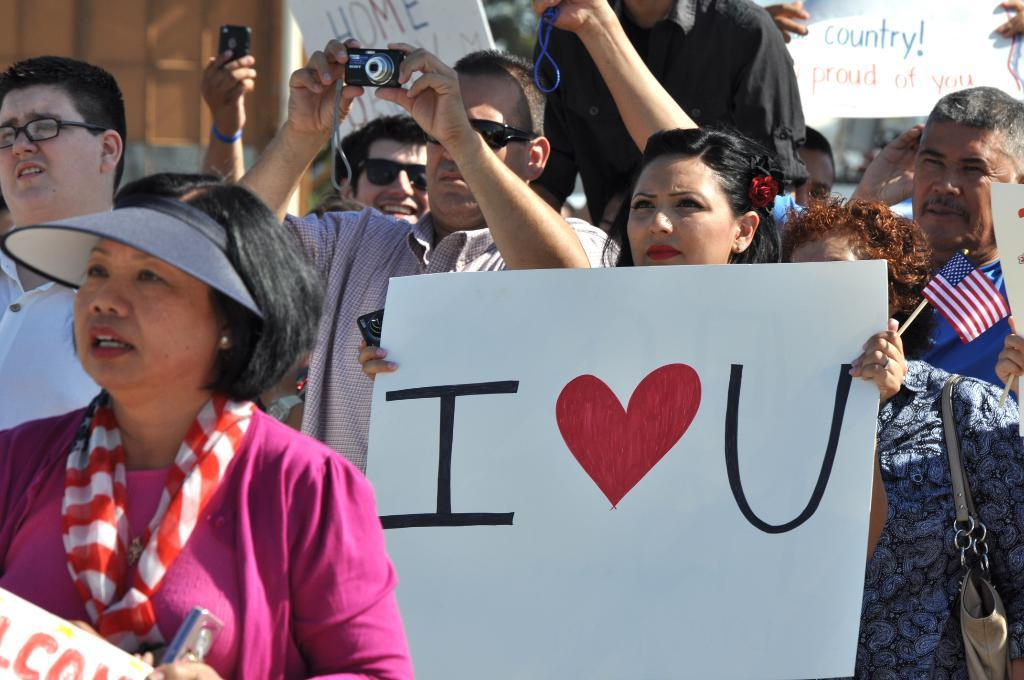What can be observed about the people in the image? There are people in the image, and some of them are holding boards. What is the man in the image doing? The man is holding a camera. Can you describe the background of the image? The background of the image is blurry. What type of silk is being used to cover the fowl in the image? There is no silk or fowl present in the image. What degree of difficulty is the man holding the camera experiencing in the image? The image does not provide any information about the man's experience or the degree of difficulty he might be facing while holding the camera. 